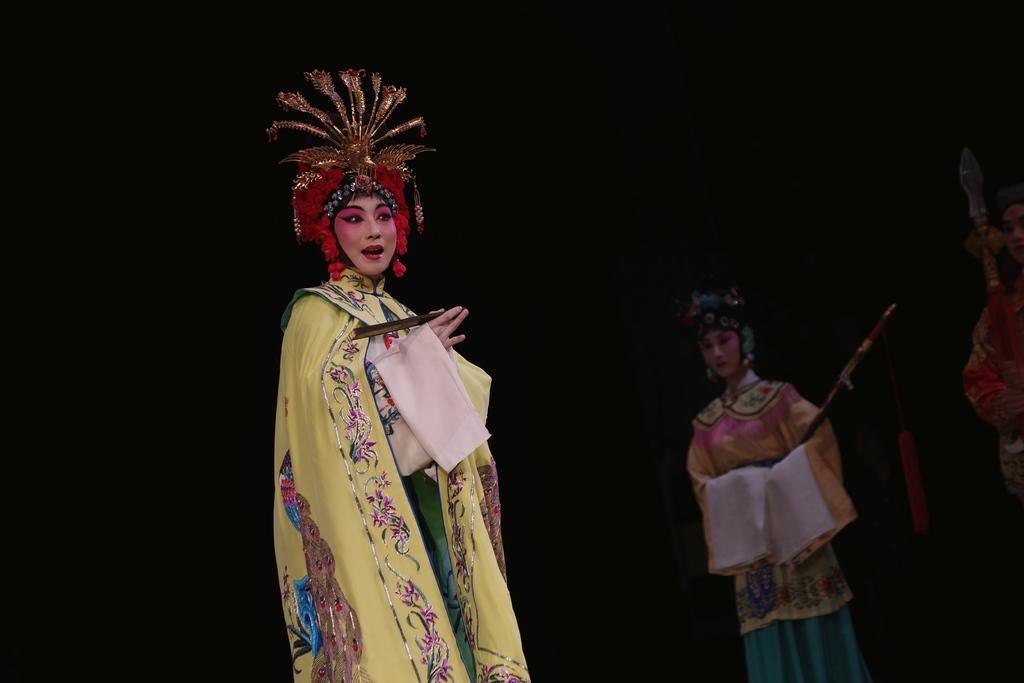In one or two sentences, can you explain what this image depicts? In this picture we can see people wearing costumes and performing on the stage looking at someone. 